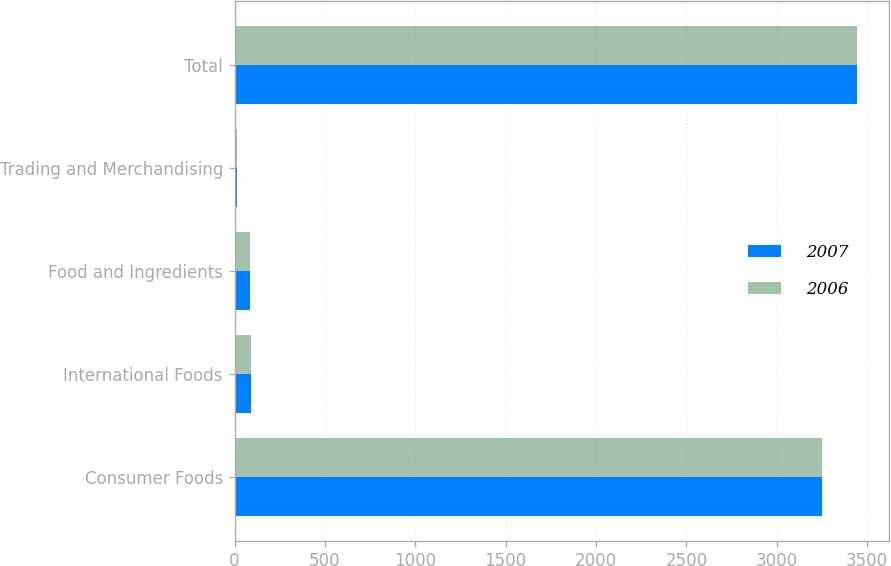Convert chart to OTSL. <chart><loc_0><loc_0><loc_500><loc_500><stacked_bar_chart><ecel><fcel>Consumer Foods<fcel>International Foods<fcel>Food and Ingredients<fcel>Trading and Merchandising<fcel>Total<nl><fcel>2007<fcel>3252.1<fcel>91.3<fcel>87.6<fcel>15.9<fcel>3446.9<nl><fcel>2006<fcel>3253<fcel>89.4<fcel>87.3<fcel>15.9<fcel>3445.6<nl></chart> 